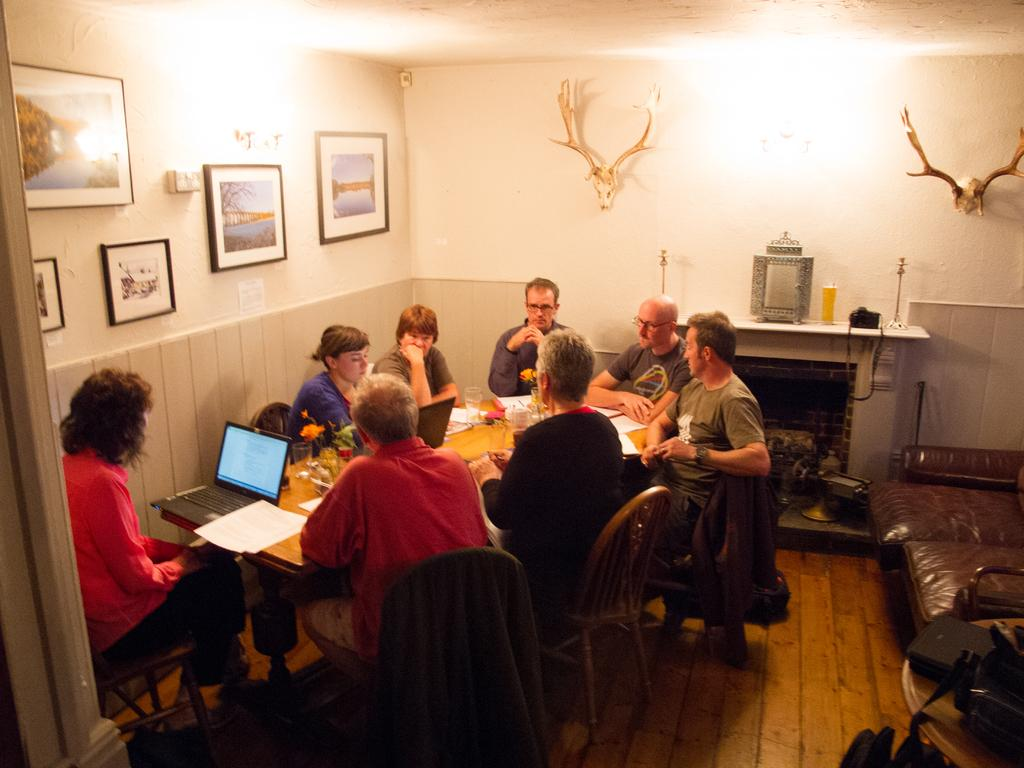How many people are in the image? There is a group of people in the image. What are the people doing in the image? The people are sitting around a table. What can be seen in the background of the image? There is a wall in the background of the image. What is on the wall in the image? The wall has photo frames on it. What substance is the elbow made of in the image? There is no mention of an elbow in the image, so it cannot be determined what substance it might be made of. 